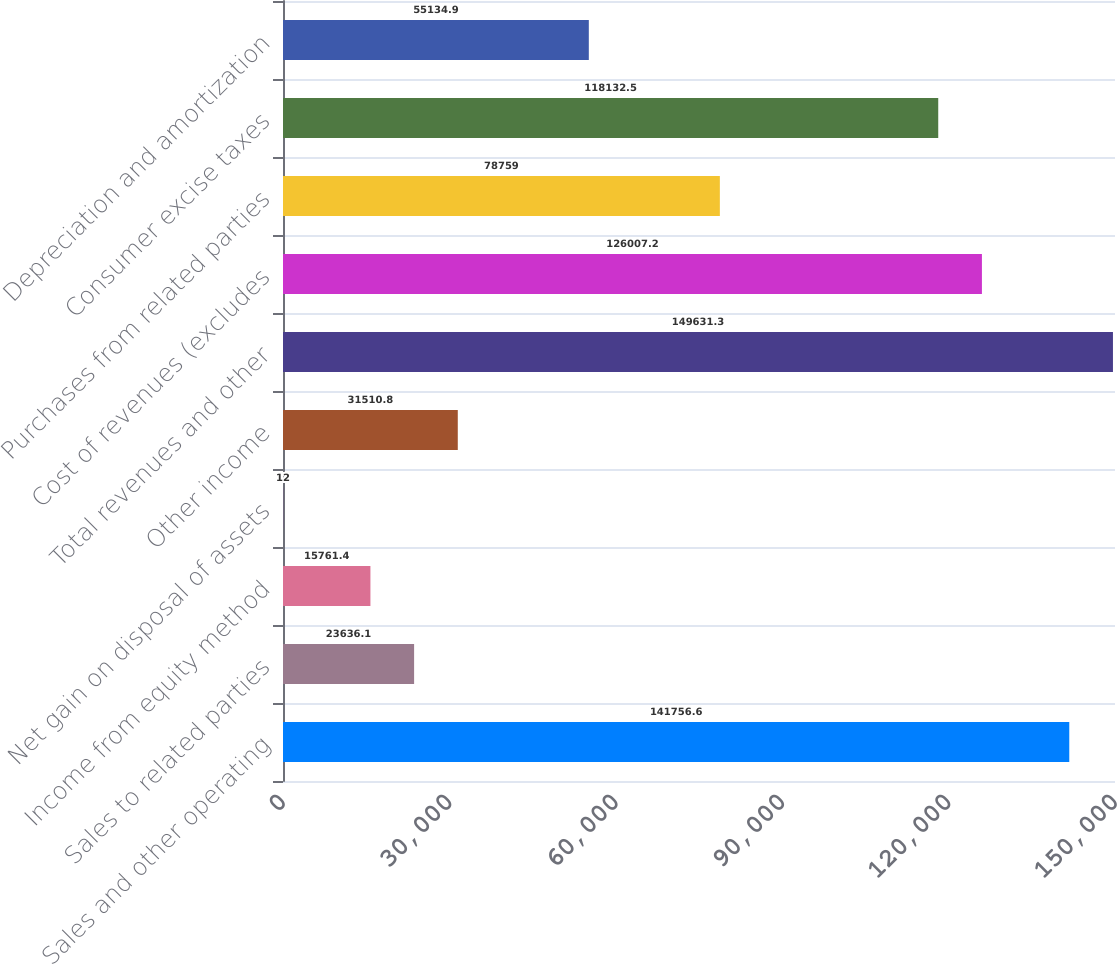Convert chart. <chart><loc_0><loc_0><loc_500><loc_500><bar_chart><fcel>Sales and other operating<fcel>Sales to related parties<fcel>Income from equity method<fcel>Net gain on disposal of assets<fcel>Other income<fcel>Total revenues and other<fcel>Cost of revenues (excludes<fcel>Purchases from related parties<fcel>Consumer excise taxes<fcel>Depreciation and amortization<nl><fcel>141757<fcel>23636.1<fcel>15761.4<fcel>12<fcel>31510.8<fcel>149631<fcel>126007<fcel>78759<fcel>118132<fcel>55134.9<nl></chart> 